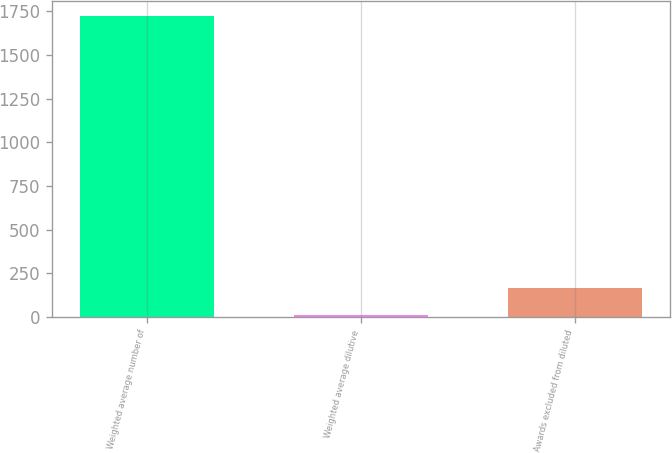<chart> <loc_0><loc_0><loc_500><loc_500><bar_chart><fcel>Weighted average number of<fcel>Weighted average dilutive<fcel>Awards excluded from diluted<nl><fcel>1724.8<fcel>10<fcel>166.8<nl></chart> 